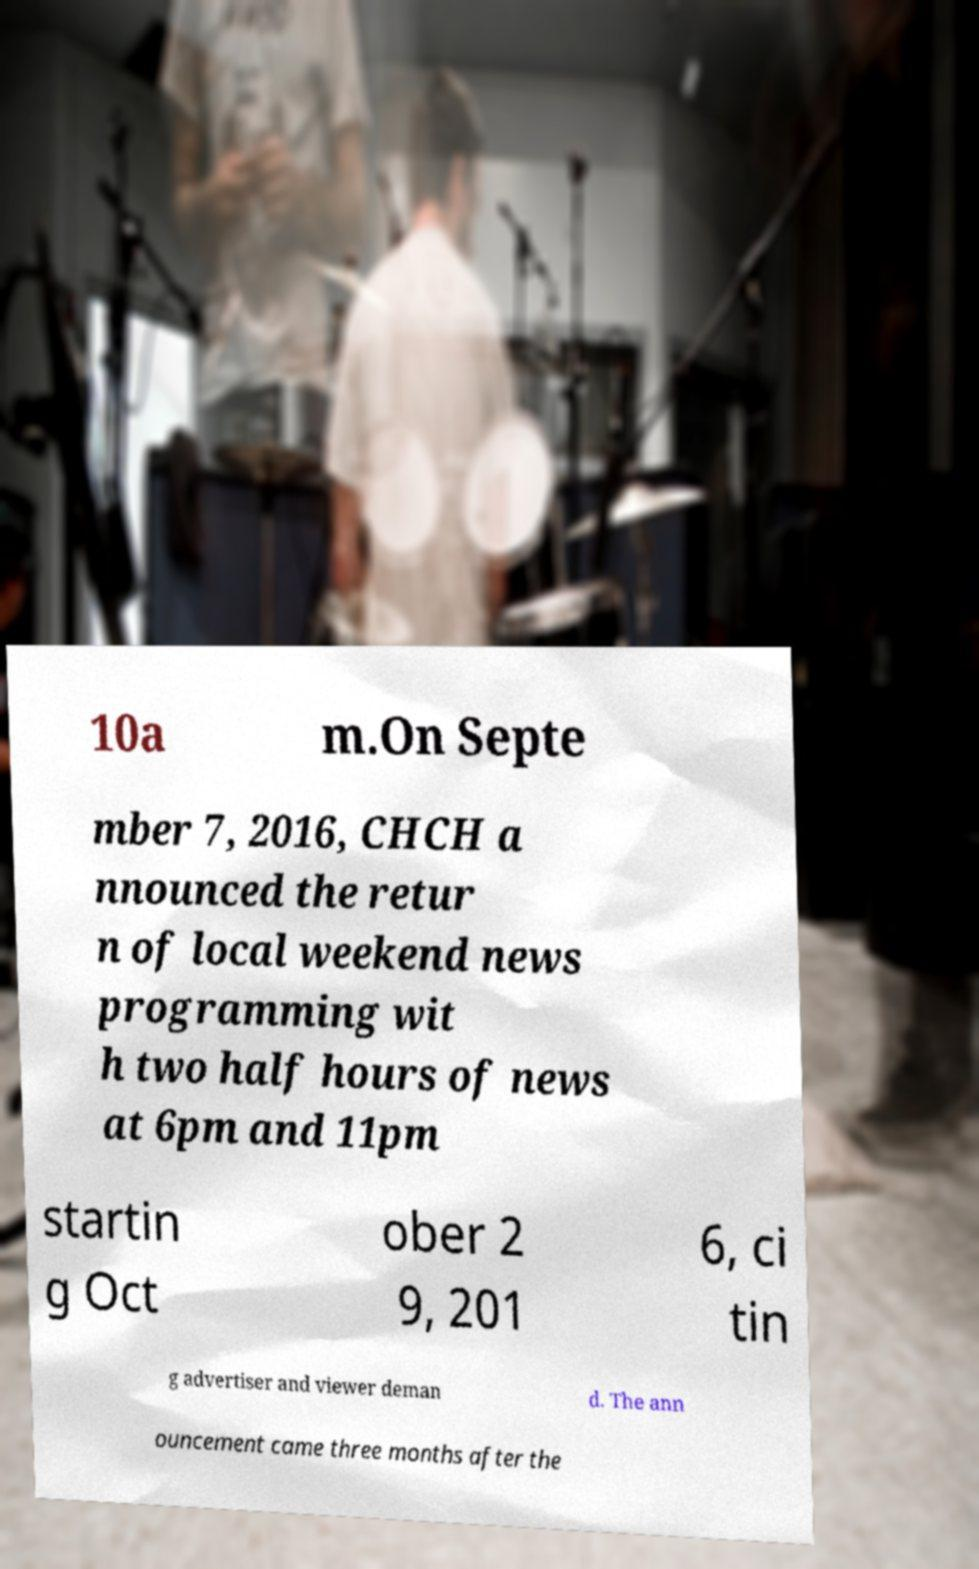What messages or text are displayed in this image? I need them in a readable, typed format. 10a m.On Septe mber 7, 2016, CHCH a nnounced the retur n of local weekend news programming wit h two half hours of news at 6pm and 11pm startin g Oct ober 2 9, 201 6, ci tin g advertiser and viewer deman d. The ann ouncement came three months after the 